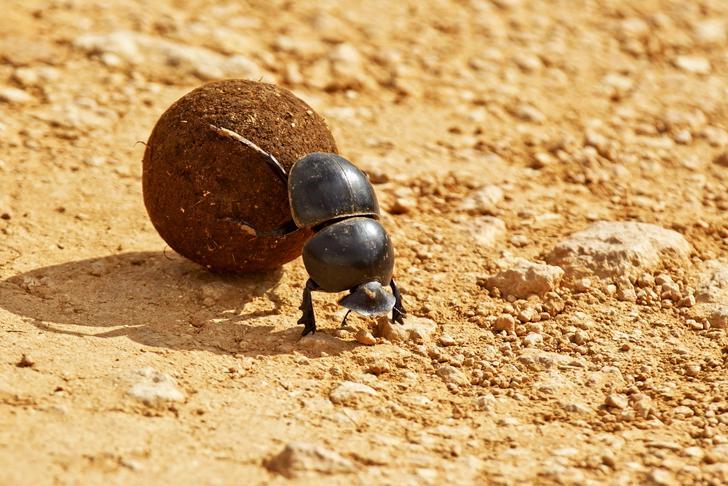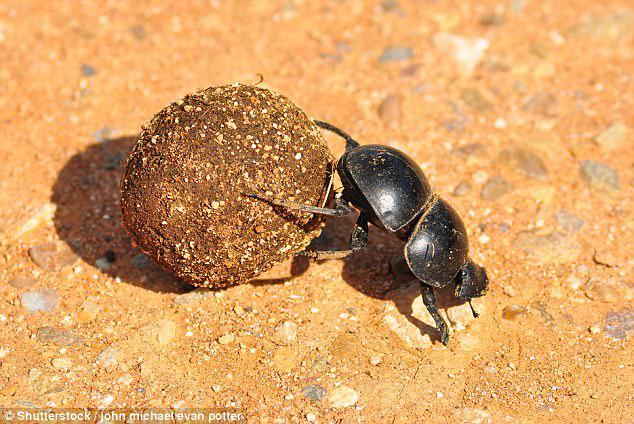The first image is the image on the left, the second image is the image on the right. Analyze the images presented: Is the assertion "Each image shows exactly one dark beetle in contact with one brown ball." valid? Answer yes or no. Yes. The first image is the image on the left, the second image is the image on the right. For the images shown, is this caption "There is no dung in one image." true? Answer yes or no. No. 